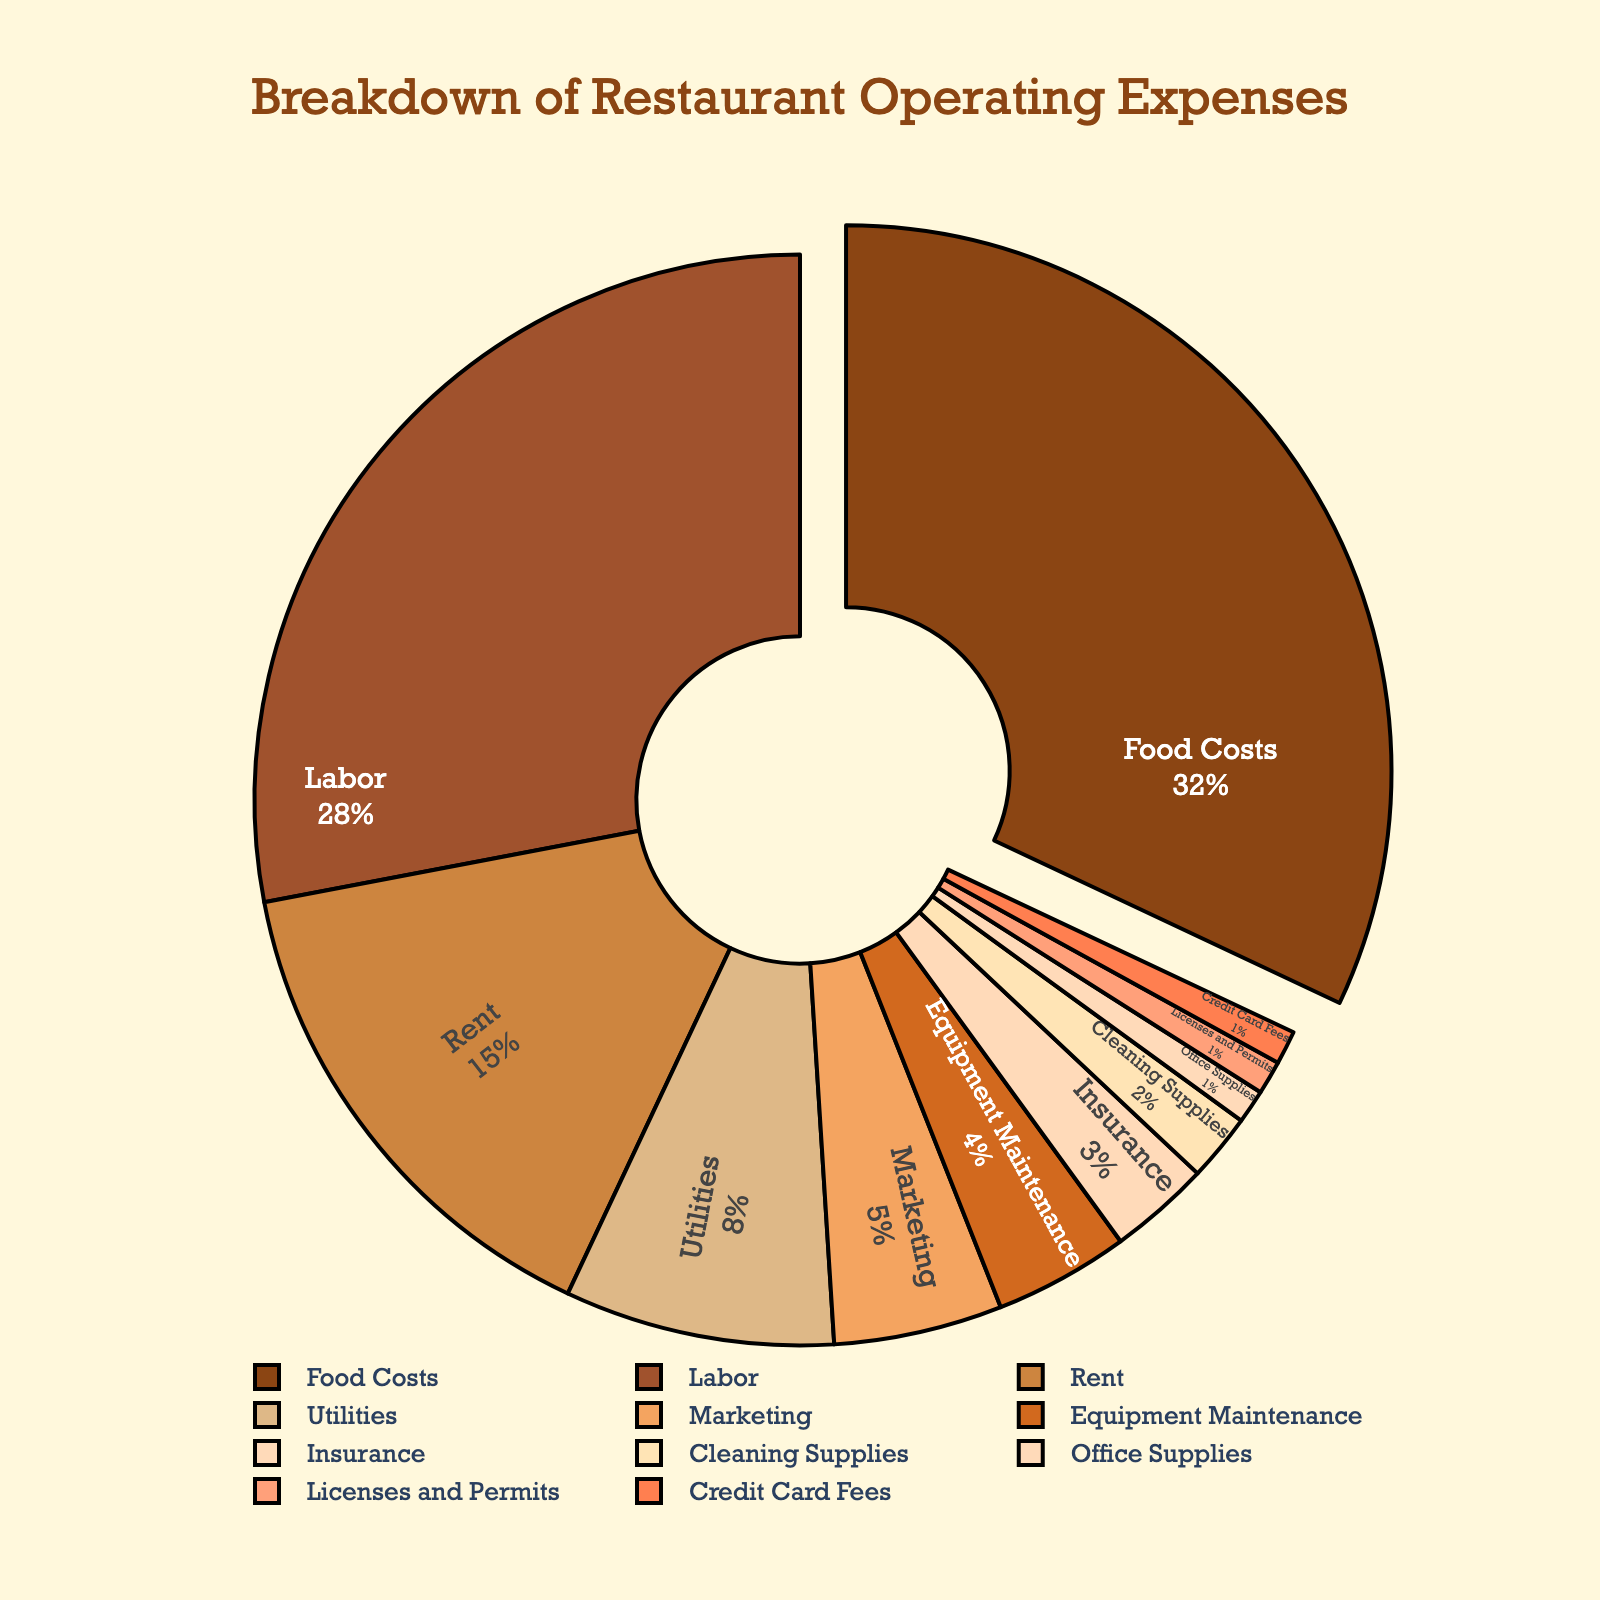Which category has the highest percentage of operating expenses? Look at the pie chart and identify the segment with the largest section, marked as Food Costs.
Answer: Food Costs What is the total percentage of operating expenses for Labor and Rent combined? Sum the percentages for Labor and Rent: 28% + 15% = 43%.
Answer: 43% Is the percentage of Utilities expense greater than Marketing expense? Compare the percentages for Utilities (8%) and Marketing (5%). Utilities is greater.
Answer: Yes What is the percentage difference between Food Costs and Labor? Find the difference between Food Costs (32%) and Labor (28%): 32% - 28% = 4%.
Answer: 4% How do the combined percentages of Equipment Maintenance and Insurance compare to Rent? Add the percentages for Equipment Maintenance (4%) and Insurance (3%): 4% + 3% = 7%. Then compare 7% to Rent (15%).
Answer: 7% is less than Rent If you combine the percentages of Office Supplies, Licenses and Permits, and Credit Card Fees, what is the total percentage? Summing the percentages: Office Supplies (1%) + Licenses and Permits (1%) + Credit Card Fees (1%) = 3%.
Answer: 3% Which category has roughly half the percentage of Food Costs? Find a category with a percentage close to 16% (half of 32%). Labor, with 28%, is the closest higher, and Rent, with 15%, is the closest lower.
Answer: Rent Is the total percentage of Marketing and Cleaning Supplies more than 10%? Add the percentages for Marketing (5%) and Cleaning Supplies (2%): 5% + 2% = 7%, which is less than 10%.
Answer: No What is the smallest expense category and its percentage? Identify the smallest segment in the pie chart, which is split among Office Supplies, Licenses and Permits, and Credit Card Fees at 1% each.
Answer: Office Supplies, Licenses and Permits, Credit Card Fees (1% each) How many expense categories are greater than 5%? Count the categories with percentages above 5%: Food Costs (32%), Labor (28%), Rent (15%), and Utilities (8%). There are four categories.
Answer: 4 